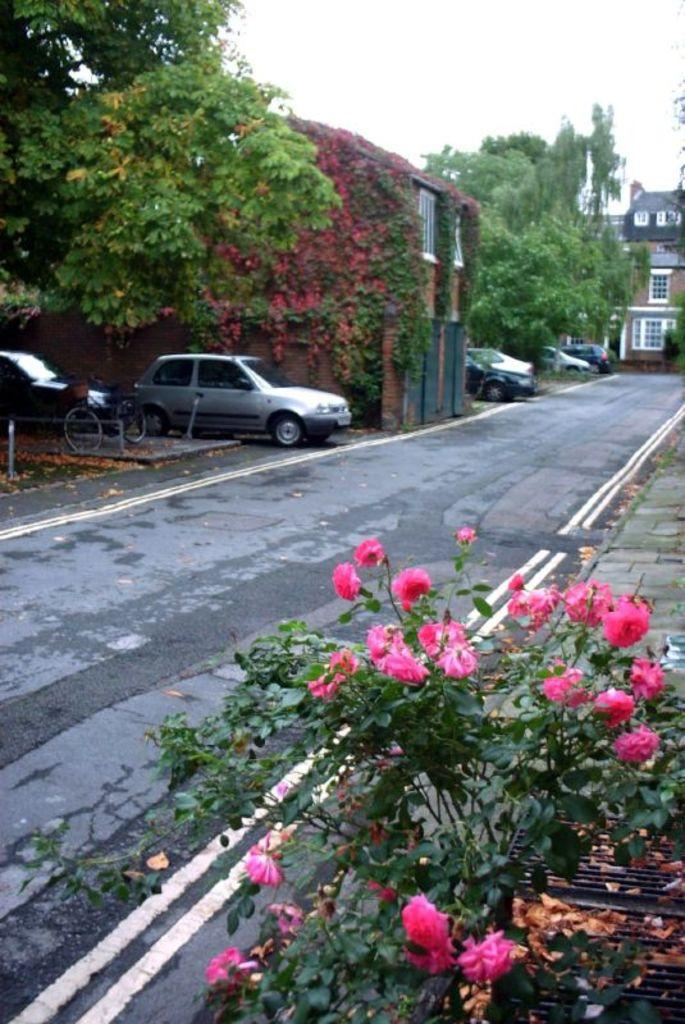What type of structures can be seen in the image? There are buildings in the image. What else can be found in the image besides buildings? There are vehicles parked, a road, trees, plants, and flowers in the image. Can you describe the road in the image? The road is visible in the image. What is visible in the background of the image? The sky is visible in the background of the image. What type of soup is being served in the image? There is no soup present in the image. Can you tell me how many jokes are being told in the image? There is no humor or jokes being depicted in the image. 